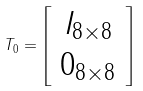Convert formula to latex. <formula><loc_0><loc_0><loc_500><loc_500>T _ { 0 } = \left [ \begin{array} { c } I _ { 8 \times 8 } \\ 0 _ { 8 \times 8 } \end{array} \right ]</formula> 